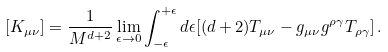<formula> <loc_0><loc_0><loc_500><loc_500>[ K _ { \mu \nu } ] = \frac { 1 } { M ^ { d + 2 } } \lim _ { \epsilon \to 0 } \int _ { - \epsilon } ^ { + \epsilon } d \epsilon [ ( d + 2 ) T _ { \mu \nu } - g _ { \mu \nu } g ^ { \rho \gamma } T _ { \rho \gamma } ] \, .</formula> 